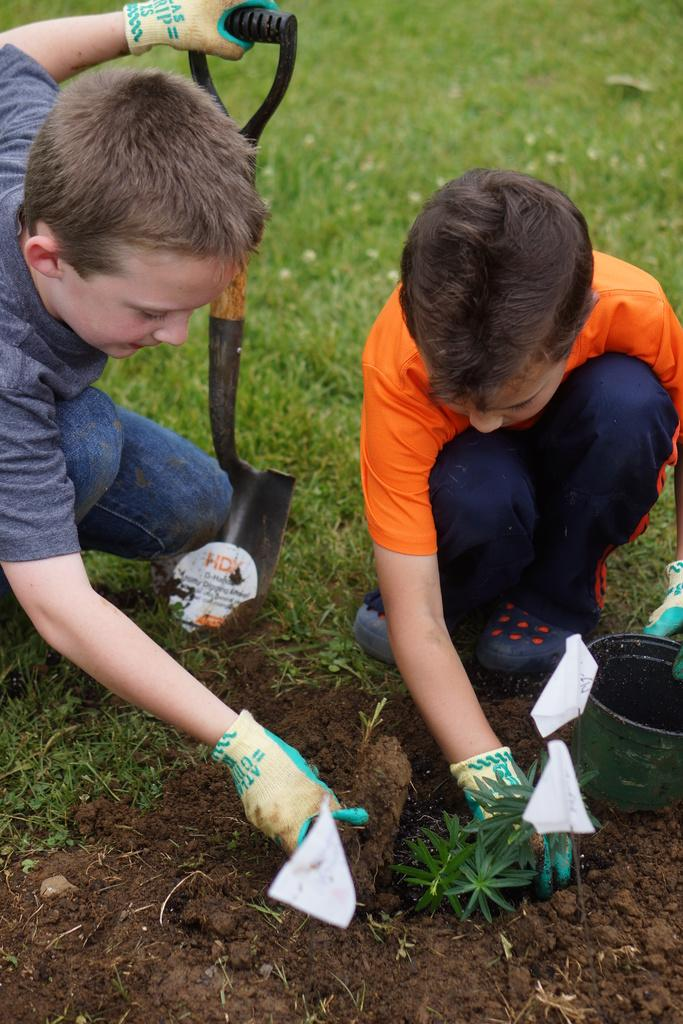How many children are present in the image? There are two children in the image. What are the children holding in their hands? One child is holding some objects, while the other child is holding a pot. What can be seen in the background of the image? There are flags visible in the image. What type of surface is visible in the image? There is grass in the image. How many goldfish are swimming in the pot held by the child in the image? There are no goldfish present in the image; the child is holding a pot, but it is not specified what is inside the pot. Can you tell me the name of the friend who is with the children in the image? There is no friend visible in the image; only the two children are present. 